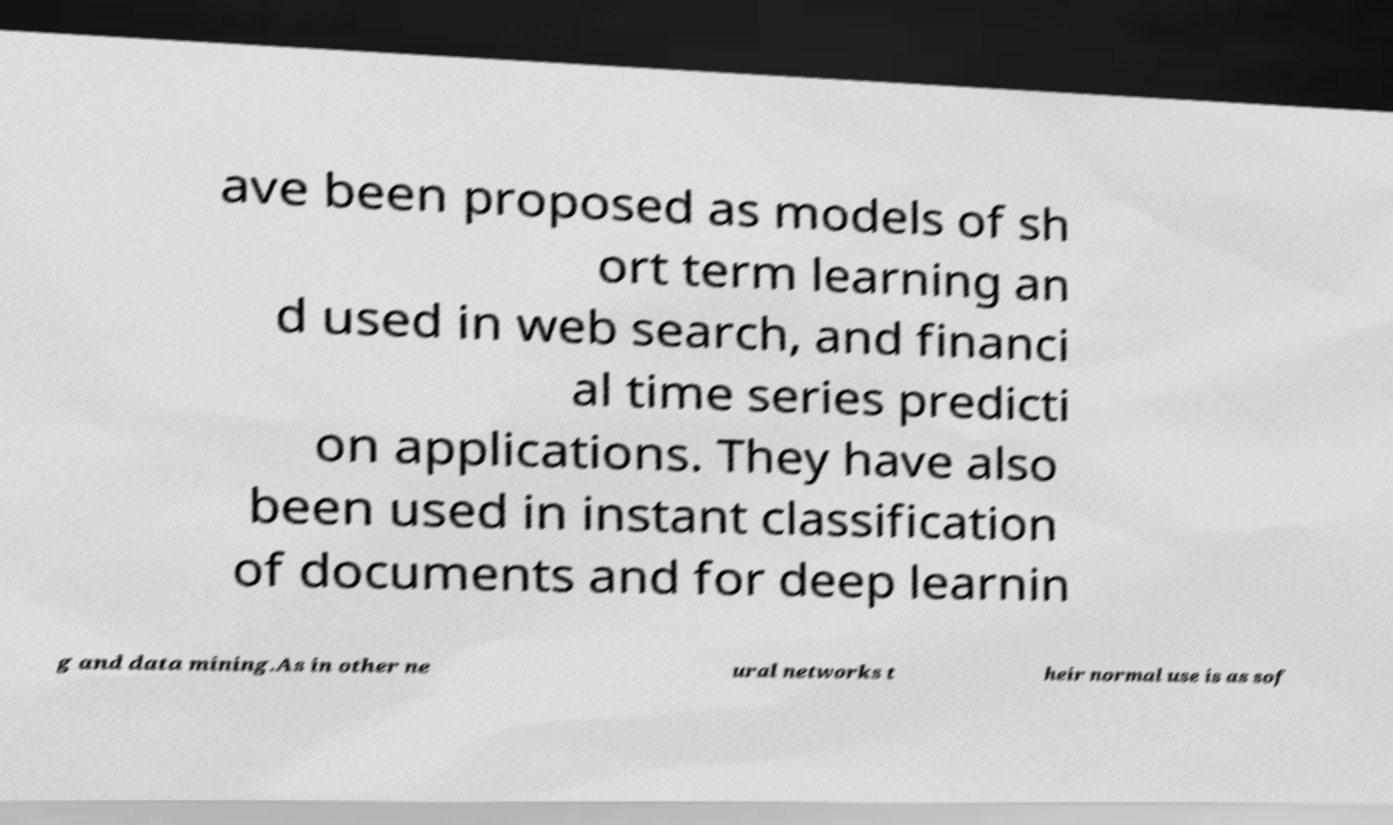Please identify and transcribe the text found in this image. ave been proposed as models of sh ort term learning an d used in web search, and financi al time series predicti on applications. They have also been used in instant classification of documents and for deep learnin g and data mining.As in other ne ural networks t heir normal use is as sof 